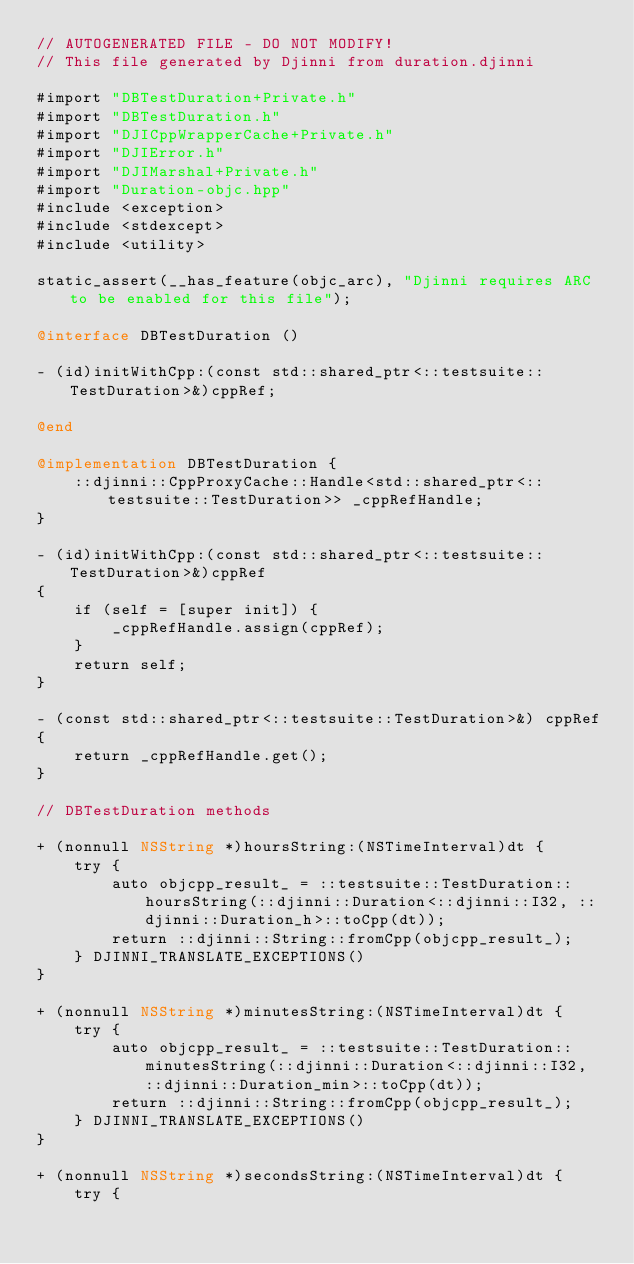<code> <loc_0><loc_0><loc_500><loc_500><_ObjectiveC_>// AUTOGENERATED FILE - DO NOT MODIFY!
// This file generated by Djinni from duration.djinni

#import "DBTestDuration+Private.h"
#import "DBTestDuration.h"
#import "DJICppWrapperCache+Private.h"
#import "DJIError.h"
#import "DJIMarshal+Private.h"
#import "Duration-objc.hpp"
#include <exception>
#include <stdexcept>
#include <utility>

static_assert(__has_feature(objc_arc), "Djinni requires ARC to be enabled for this file");

@interface DBTestDuration ()

- (id)initWithCpp:(const std::shared_ptr<::testsuite::TestDuration>&)cppRef;

@end

@implementation DBTestDuration {
    ::djinni::CppProxyCache::Handle<std::shared_ptr<::testsuite::TestDuration>> _cppRefHandle;
}

- (id)initWithCpp:(const std::shared_ptr<::testsuite::TestDuration>&)cppRef
{
    if (self = [super init]) {
        _cppRefHandle.assign(cppRef);
    }
    return self;
}

- (const std::shared_ptr<::testsuite::TestDuration>&) cppRef
{
    return _cppRefHandle.get();
}

// DBTestDuration methods

+ (nonnull NSString *)hoursString:(NSTimeInterval)dt {
    try {
        auto objcpp_result_ = ::testsuite::TestDuration::hoursString(::djinni::Duration<::djinni::I32, ::djinni::Duration_h>::toCpp(dt));
        return ::djinni::String::fromCpp(objcpp_result_);
    } DJINNI_TRANSLATE_EXCEPTIONS()
}

+ (nonnull NSString *)minutesString:(NSTimeInterval)dt {
    try {
        auto objcpp_result_ = ::testsuite::TestDuration::minutesString(::djinni::Duration<::djinni::I32, ::djinni::Duration_min>::toCpp(dt));
        return ::djinni::String::fromCpp(objcpp_result_);
    } DJINNI_TRANSLATE_EXCEPTIONS()
}

+ (nonnull NSString *)secondsString:(NSTimeInterval)dt {
    try {</code> 